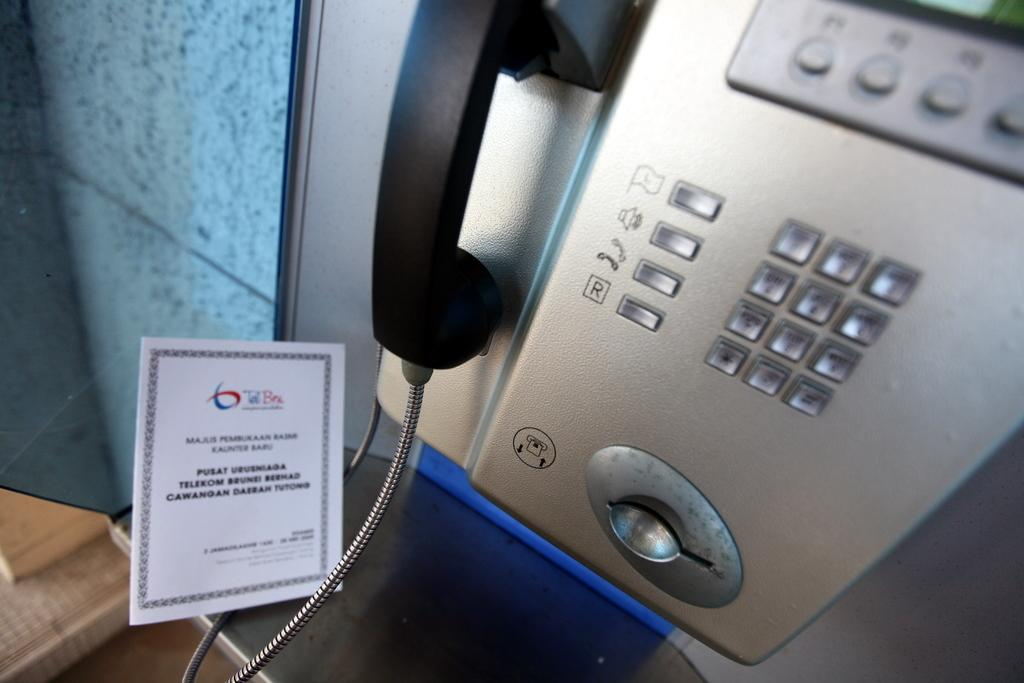What type of communication device is present in the image? There is a telephone in the image. What is the other object made of glass in the image? There is a glass in the image. What is the third object in the image made of? There is a board in the image. Where are these objects located? These objects are on a platform. What can be seen through the glass in the image? The glass allows a view of the wall through it. What type of meat is being cooked on the roof in the image? There is no meat or roof present in the image. 